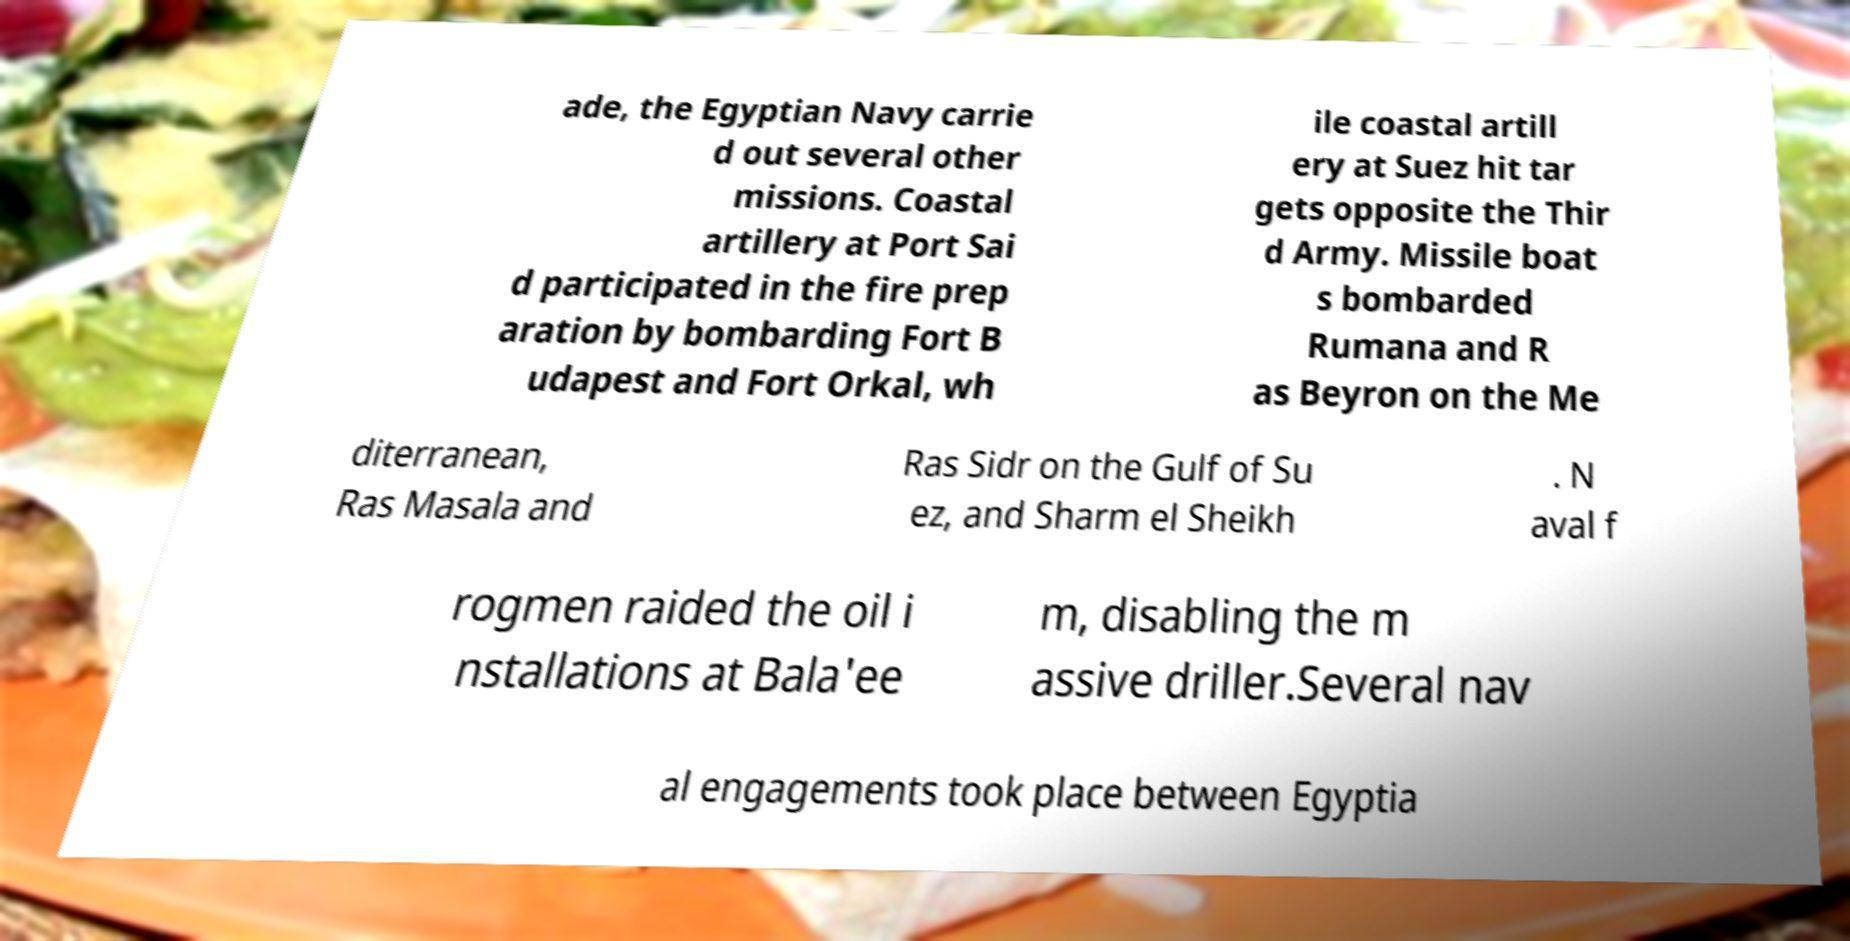For documentation purposes, I need the text within this image transcribed. Could you provide that? ade, the Egyptian Navy carrie d out several other missions. Coastal artillery at Port Sai d participated in the fire prep aration by bombarding Fort B udapest and Fort Orkal, wh ile coastal artill ery at Suez hit tar gets opposite the Thir d Army. Missile boat s bombarded Rumana and R as Beyron on the Me diterranean, Ras Masala and Ras Sidr on the Gulf of Su ez, and Sharm el Sheikh . N aval f rogmen raided the oil i nstallations at Bala'ee m, disabling the m assive driller.Several nav al engagements took place between Egyptia 